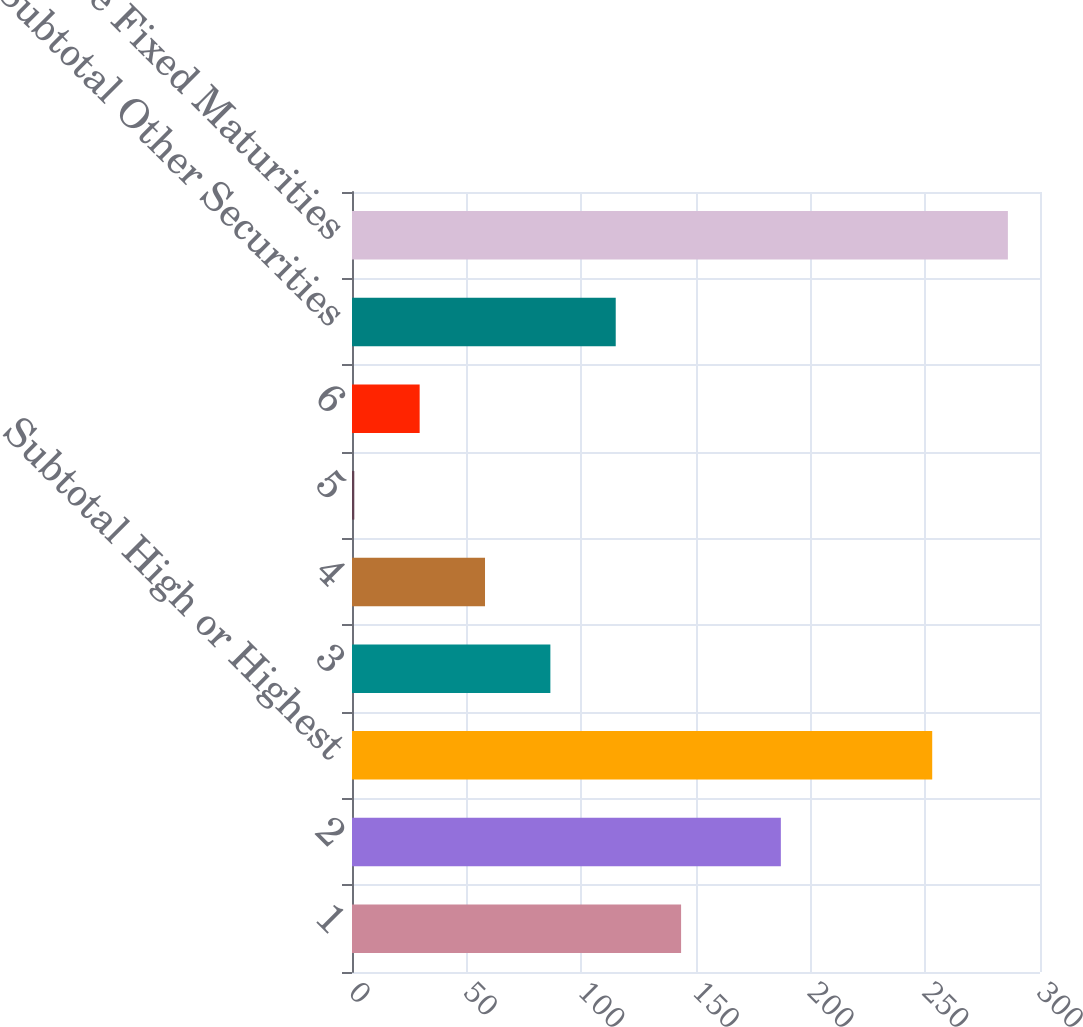<chart> <loc_0><loc_0><loc_500><loc_500><bar_chart><fcel>1<fcel>2<fcel>Subtotal High or Highest<fcel>3<fcel>4<fcel>5<fcel>6<fcel>Subtotal Other Securities<fcel>Total Private Fixed Maturities<nl><fcel>143.5<fcel>187<fcel>253<fcel>86.5<fcel>58<fcel>1<fcel>29.5<fcel>115<fcel>286<nl></chart> 